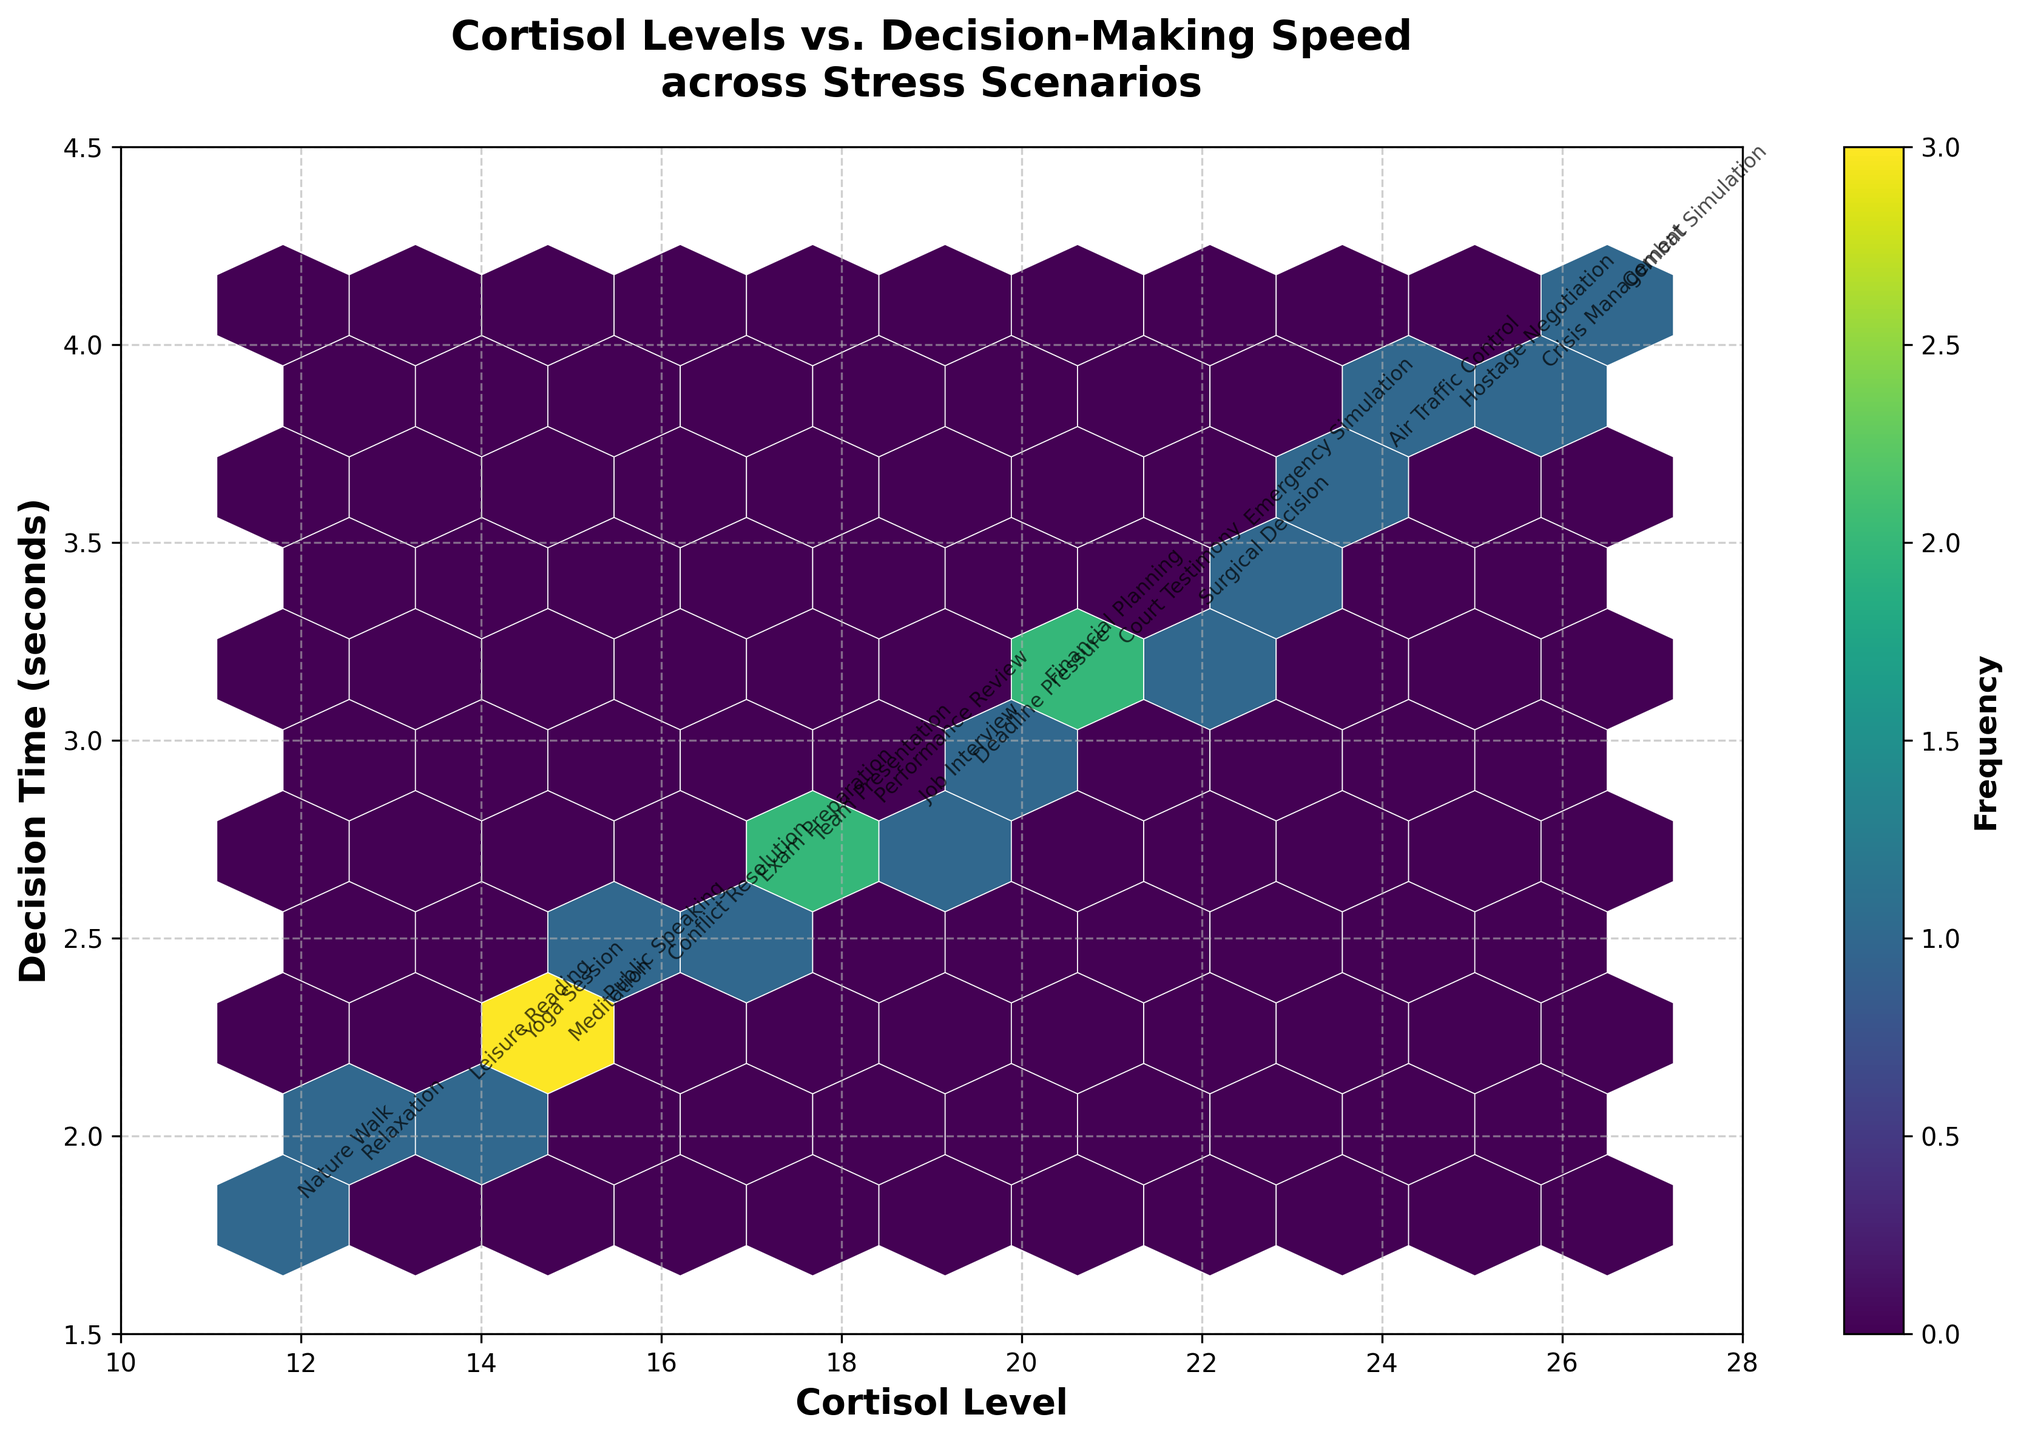What is the title of the figure? The title is prominently displayed at the top of the figure and it reads "Cortisol Levels vs. Decision-Making Speed across Stress Scenarios".
Answer: Cortisol Levels vs. Decision-Making Speed across Stress Scenarios How many stress scenarios are annotated in the figure? By looking at the annotations, each stress scenario is labeled next to its corresponding data point, totaling 20 unique scenarios.
Answer: 20 What is the range of Cortisol levels presented in the figure? The x-axis, labeled "Cortisol Level", spans from 10 to 28. This range is also visible from the data points in the figure.
Answer: 10 to 28 Which stress scenario has the highest decision time and what is its value? The scenario "Combat Simulation" is annotated at the highest decision time on the y-axis, which is 4.1 seconds.
Answer: Combat Simulation, 4.1 seconds Are there more data points clustered at higher or lower Cortisol levels? By observing the density of the hexbin plot, more data points are clustered towards the mid to higher range of Cortisol levels (around 15-25). This is indicated by darker, more frequent hexagons in that range.
Answer: Mid to higher Cortisol levels What is the most common decision time range for the data points? The color intensity in the hexbin plot shows that the majority of data points fall within the 2.5 to 3.5 seconds range on the y-axis.
Answer: 2.5 to 3.5 seconds Which data point corresponds to the "Meditation" stress scenario and what are its Cortisol level and decision time? The annotation "Meditation" is placed next to the data point with a Cortisol level of 14.8 and a decision time of 2.2 seconds.
Answer: 14.8 Cortisol Level, 2.2 seconds What is the difference in decision time between "Nature Walk" and "Public Speaking"? "Nature Walk" has a decision time of 1.8 seconds, and "Public Speaking" has a decision time of 2.3 seconds. The difference is calculated as 2.3 - 1.8.
Answer: 0.5 seconds Which stress scenario has the lowest Cortisol level and what is the corresponding decision time? "Nature Walk" has the lowest Cortisol level at 11.8, with a corresponding decision time of 1.8 seconds, as indicated by the annotation near the lowest position on the x-axis.
Answer: Nature Walk, 1.8 seconds Is there a scenario where decision time exceeds 3.5 seconds but Cortisol level is below 20? Reviewing the annotations along with plotted points, there are no scenarios that meet both conditions: no decision times above 3.5 seconds occur with a Cortisol level below 20.
Answer: No 